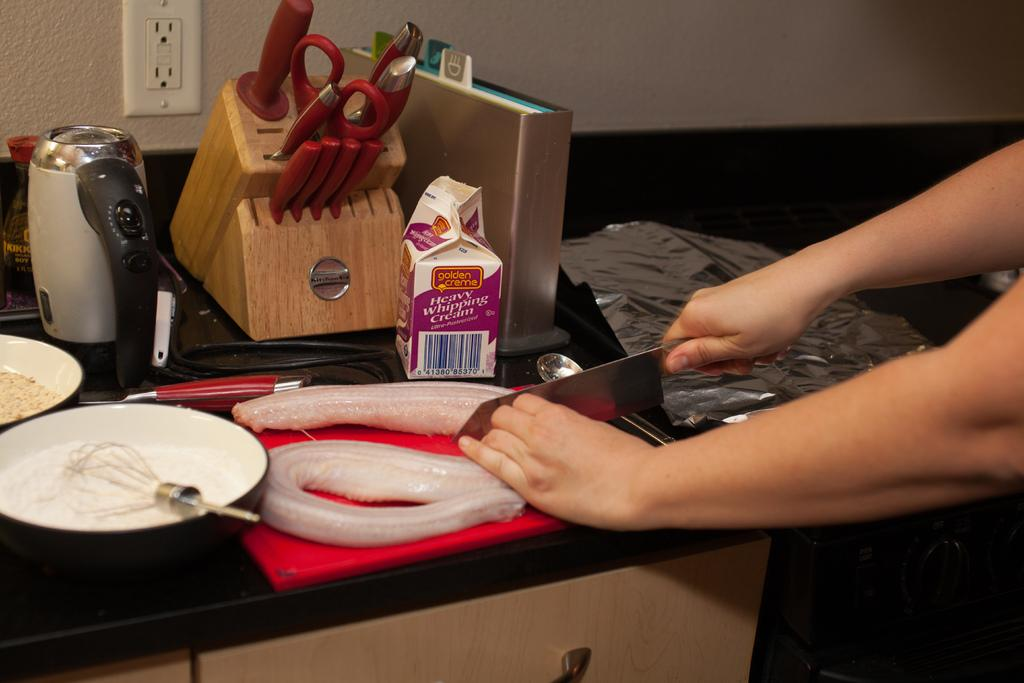<image>
Offer a succinct explanation of the picture presented. A person prepares food that will use heavy whipping cream. 